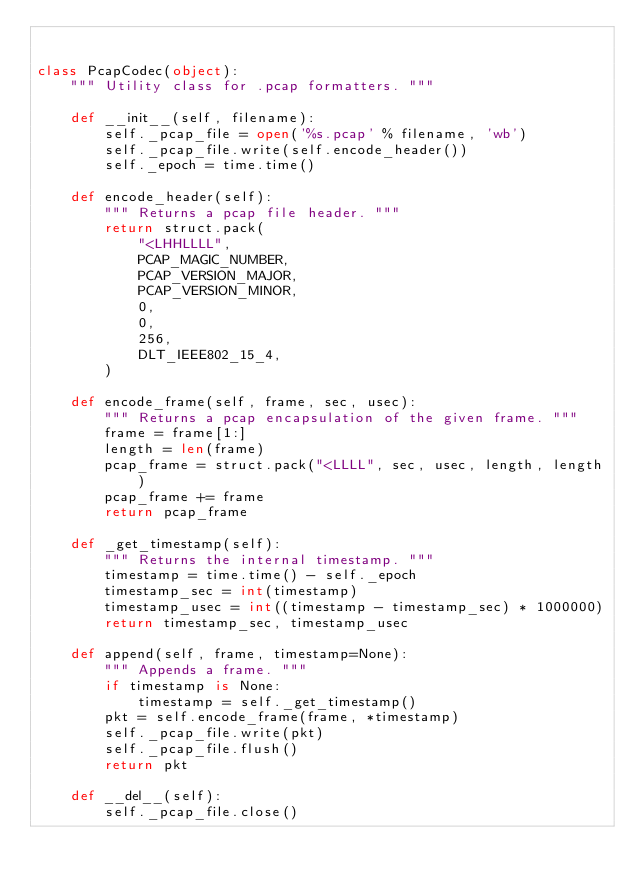Convert code to text. <code><loc_0><loc_0><loc_500><loc_500><_Python_>

class PcapCodec(object):
    """ Utility class for .pcap formatters. """

    def __init__(self, filename):
        self._pcap_file = open('%s.pcap' % filename, 'wb')
        self._pcap_file.write(self.encode_header())
        self._epoch = time.time()

    def encode_header(self):
        """ Returns a pcap file header. """
        return struct.pack(
            "<LHHLLLL",
            PCAP_MAGIC_NUMBER,
            PCAP_VERSION_MAJOR,
            PCAP_VERSION_MINOR,
            0,
            0,
            256,
            DLT_IEEE802_15_4,
        )

    def encode_frame(self, frame, sec, usec):
        """ Returns a pcap encapsulation of the given frame. """
        frame = frame[1:]
        length = len(frame)
        pcap_frame = struct.pack("<LLLL", sec, usec, length, length)
        pcap_frame += frame
        return pcap_frame

    def _get_timestamp(self):
        """ Returns the internal timestamp. """
        timestamp = time.time() - self._epoch
        timestamp_sec = int(timestamp)
        timestamp_usec = int((timestamp - timestamp_sec) * 1000000)
        return timestamp_sec, timestamp_usec

    def append(self, frame, timestamp=None):
        """ Appends a frame. """
        if timestamp is None:
            timestamp = self._get_timestamp()
        pkt = self.encode_frame(frame, *timestamp)
        self._pcap_file.write(pkt)
        self._pcap_file.flush()
        return pkt

    def __del__(self):
        self._pcap_file.close()
</code> 